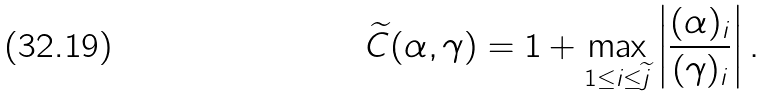<formula> <loc_0><loc_0><loc_500><loc_500>\widetilde { C } ( \alpha , \gamma ) = 1 + \max _ { 1 \leq i \leq \widetilde { j } } \left | \frac { ( \alpha ) _ { i } } { ( \gamma ) _ { i } } \right | .</formula> 